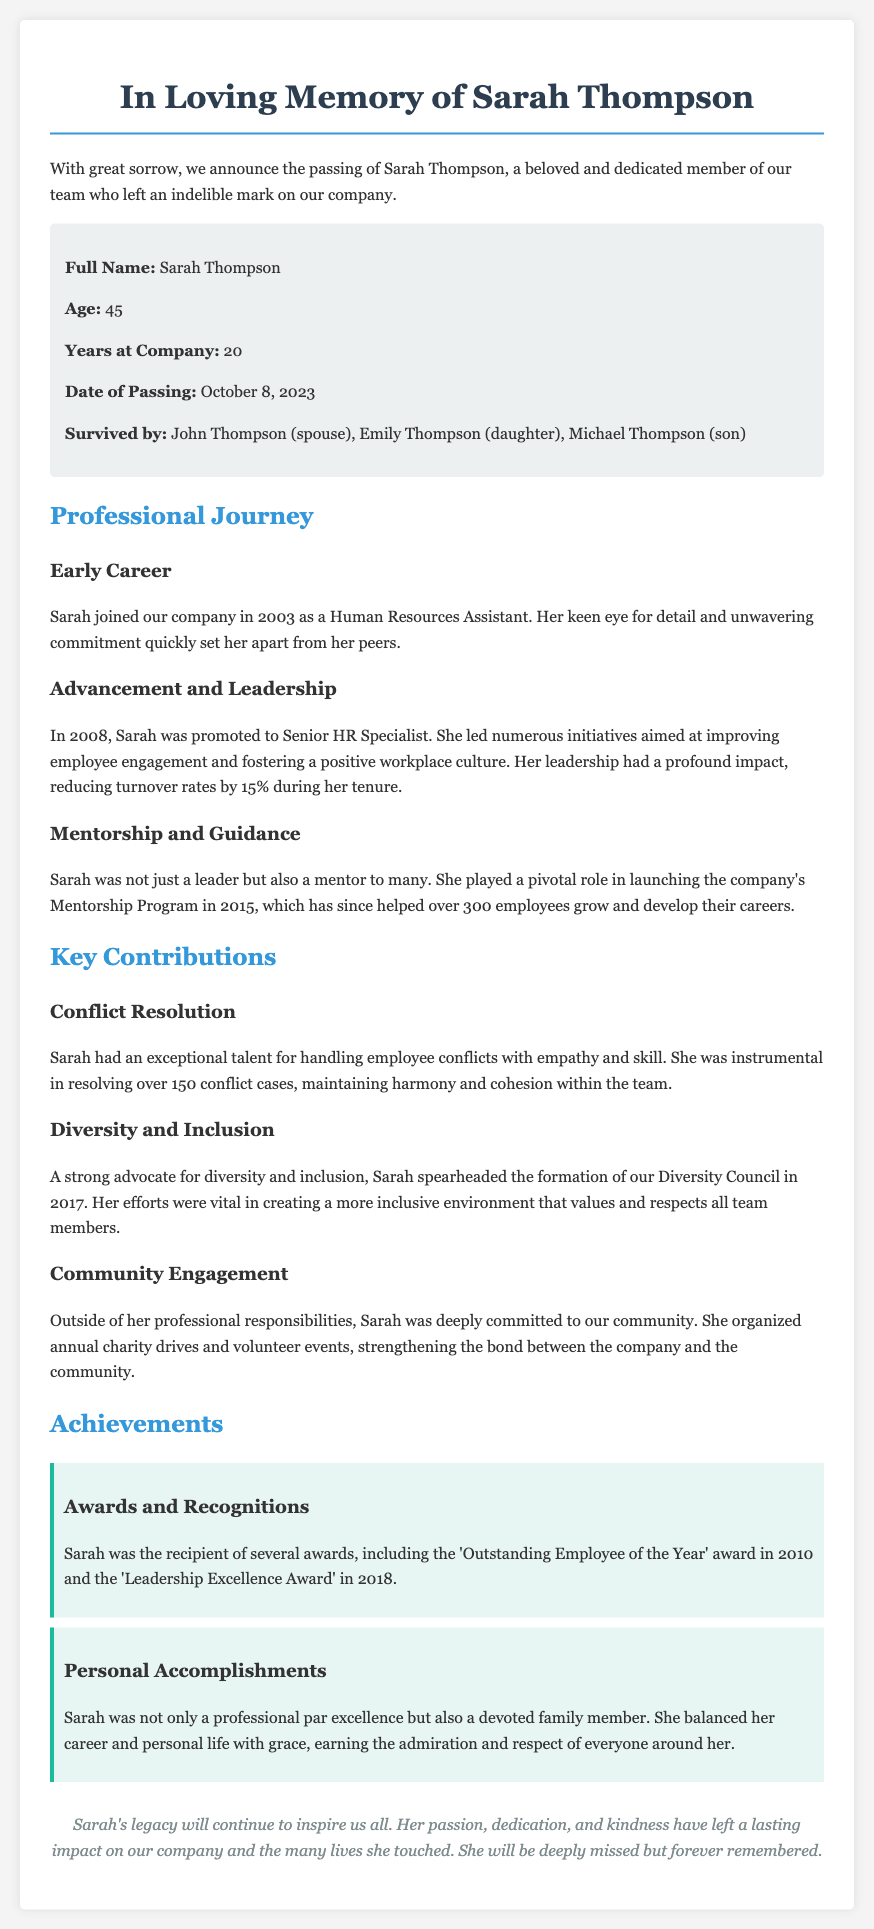What is the full name of the deceased? The full name is presented in the document as the primary focus, explicitly stated at the beginning.
Answer: Sarah Thompson What was Sarah's age at the time of passing? Sarah's age is specified in the details provided in the document.
Answer: 45 What position did Sarah hold when she joined the company? The initial role of Sarah within the company is clearly mentioned in the section about her early career.
Answer: Human Resources Assistant In what year did Sarah start working at the company? The document provides the year Sarah joined the company in the early career section.
Answer: 2003 How many years did Sarah work at the company before her passing? The document explicitly states the total duration of Sarah's service at the company.
Answer: 20 What program did Sarah launch in 2015? Sarah's contribution to the company's initiatives is highlighted, including the specific program she launched.
Answer: Mentorship Program What award did Sarah receive in 2010? The document lists specific awards that Sarah received throughout her career, which includes this particular year.
Answer: Outstanding Employee of the Year How many conflict cases did Sarah resolve? The document quantifies Sarah's contributions to conflict resolution, indicating the total number of cases she handled.
Answer: 150 What initiative did Sarah spearhead in 2017? The document details one of her key contributions focused on diversity, including the specific initiative's name and year.
Answer: Diversity Council 